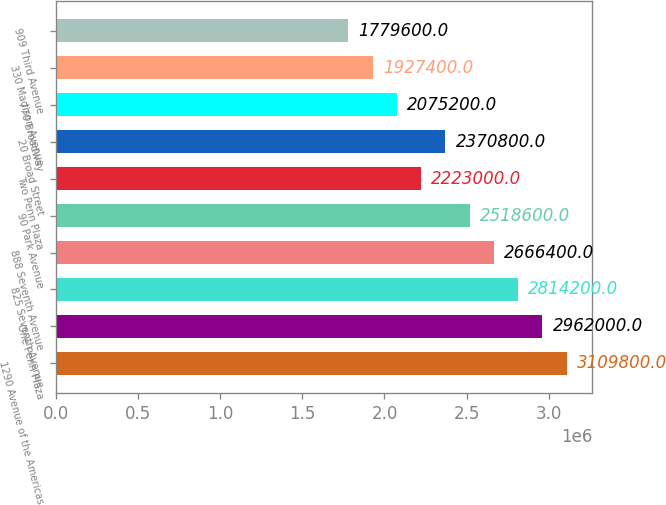<chart> <loc_0><loc_0><loc_500><loc_500><bar_chart><fcel>1290 Avenue of the Americas<fcel>One Penn Plaza<fcel>825 Seventh Avenue<fcel>888 Seventh Avenue<fcel>90 Park Avenue<fcel>Two Penn Plaza<fcel>20 Broad Street<fcel>770 Broadway<fcel>330 Madison Avenue<fcel>909 Third Avenue<nl><fcel>3.1098e+06<fcel>2.962e+06<fcel>2.8142e+06<fcel>2.6664e+06<fcel>2.5186e+06<fcel>2.223e+06<fcel>2.3708e+06<fcel>2.0752e+06<fcel>1.9274e+06<fcel>1.7796e+06<nl></chart> 